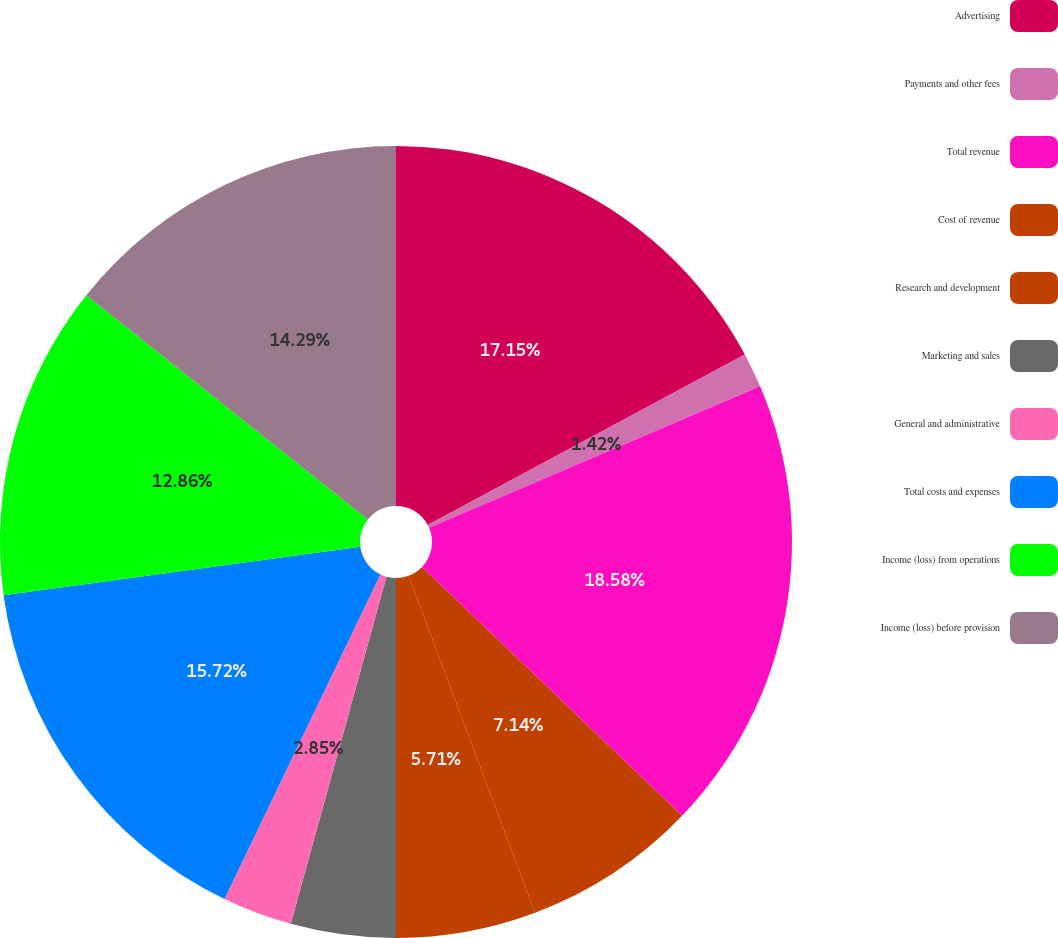Convert chart to OTSL. <chart><loc_0><loc_0><loc_500><loc_500><pie_chart><fcel>Advertising<fcel>Payments and other fees<fcel>Total revenue<fcel>Cost of revenue<fcel>Research and development<fcel>Marketing and sales<fcel>General and administrative<fcel>Total costs and expenses<fcel>Income (loss) from operations<fcel>Income (loss) before provision<nl><fcel>17.15%<fcel>1.42%<fcel>18.58%<fcel>7.14%<fcel>5.71%<fcel>4.28%<fcel>2.85%<fcel>15.72%<fcel>12.86%<fcel>14.29%<nl></chart> 